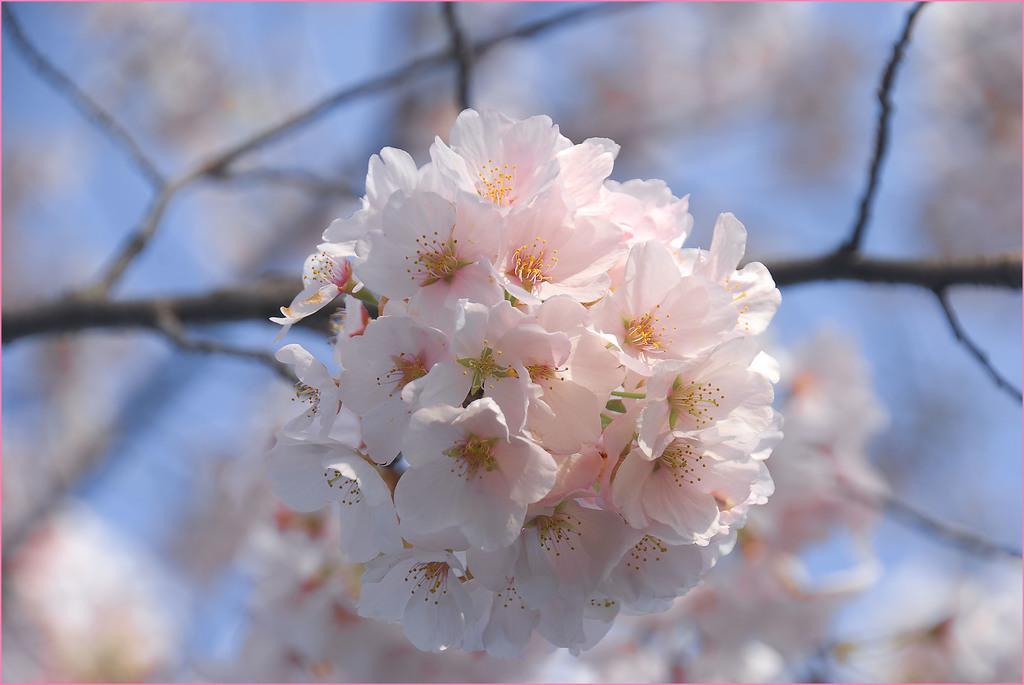Describe this image in one or two sentences. In this picture we can see flowers in the branch. On the background we can see plant. 